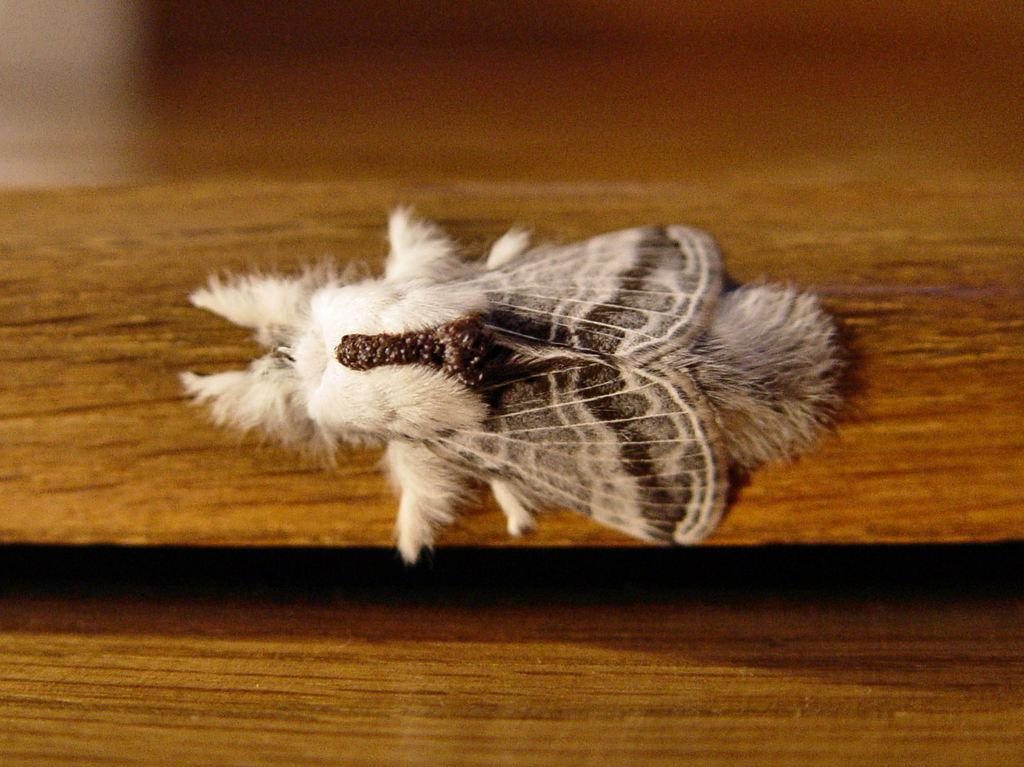What is the main subject in the center of the image? There is an insect in the center of the image. Can you describe the background of the image? There is a wooden object in the background of the image. What type of car can be seen in the image? There is no car present in the image; it features an insect and a wooden object in the background. What instrument is the insect playing in the image? There is no instrument present in the image, as it only features an insect and a wooden object in the background. 